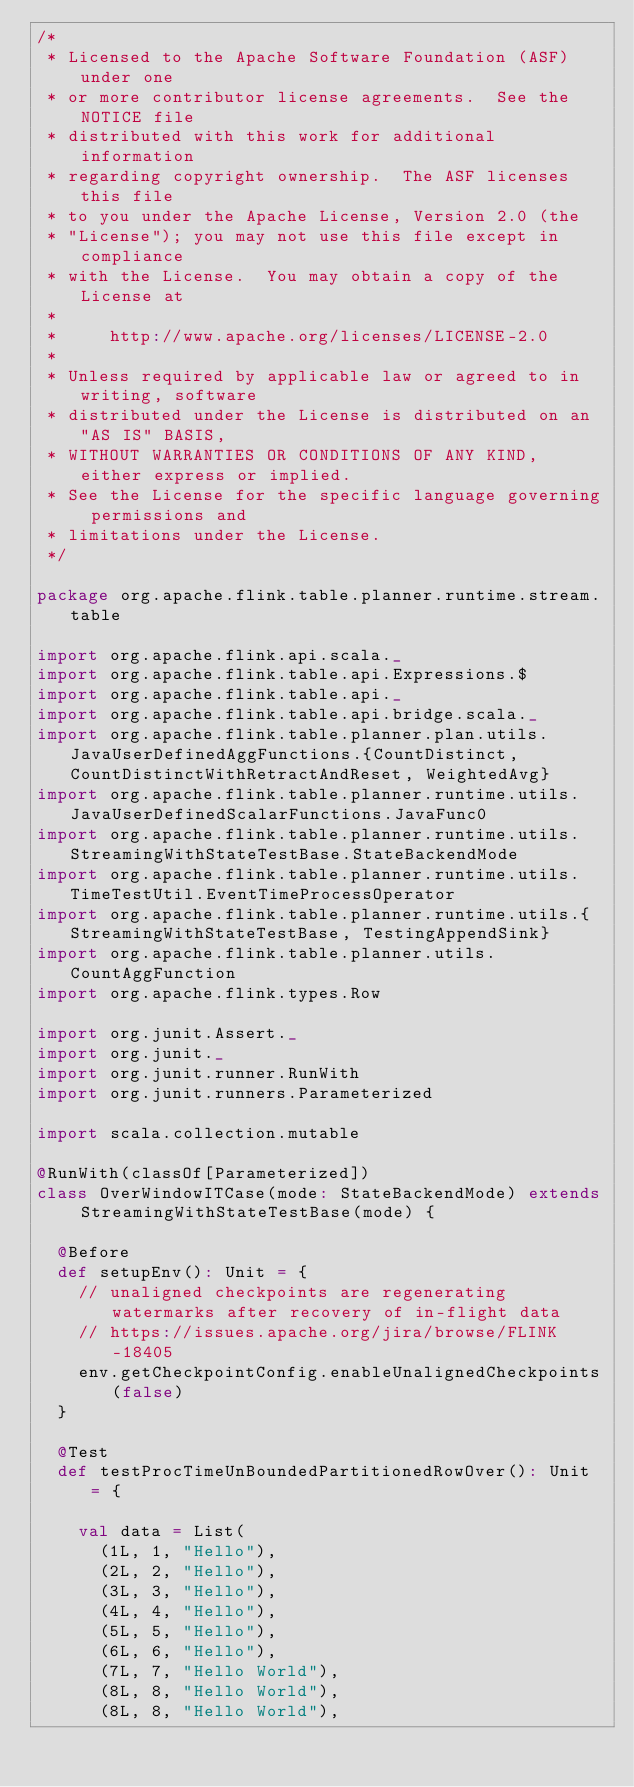<code> <loc_0><loc_0><loc_500><loc_500><_Scala_>/*
 * Licensed to the Apache Software Foundation (ASF) under one
 * or more contributor license agreements.  See the NOTICE file
 * distributed with this work for additional information
 * regarding copyright ownership.  The ASF licenses this file
 * to you under the Apache License, Version 2.0 (the
 * "License"); you may not use this file except in compliance
 * with the License.  You may obtain a copy of the License at
 *
 *     http://www.apache.org/licenses/LICENSE-2.0
 *
 * Unless required by applicable law or agreed to in writing, software
 * distributed under the License is distributed on an "AS IS" BASIS,
 * WITHOUT WARRANTIES OR CONDITIONS OF ANY KIND, either express or implied.
 * See the License for the specific language governing permissions and
 * limitations under the License.
 */

package org.apache.flink.table.planner.runtime.stream.table

import org.apache.flink.api.scala._
import org.apache.flink.table.api.Expressions.$
import org.apache.flink.table.api._
import org.apache.flink.table.api.bridge.scala._
import org.apache.flink.table.planner.plan.utils.JavaUserDefinedAggFunctions.{CountDistinct, CountDistinctWithRetractAndReset, WeightedAvg}
import org.apache.flink.table.planner.runtime.utils.JavaUserDefinedScalarFunctions.JavaFunc0
import org.apache.flink.table.planner.runtime.utils.StreamingWithStateTestBase.StateBackendMode
import org.apache.flink.table.planner.runtime.utils.TimeTestUtil.EventTimeProcessOperator
import org.apache.flink.table.planner.runtime.utils.{StreamingWithStateTestBase, TestingAppendSink}
import org.apache.flink.table.planner.utils.CountAggFunction
import org.apache.flink.types.Row

import org.junit.Assert._
import org.junit._
import org.junit.runner.RunWith
import org.junit.runners.Parameterized

import scala.collection.mutable

@RunWith(classOf[Parameterized])
class OverWindowITCase(mode: StateBackendMode) extends StreamingWithStateTestBase(mode) {

  @Before
  def setupEnv(): Unit = {
    // unaligned checkpoints are regenerating watermarks after recovery of in-flight data
    // https://issues.apache.org/jira/browse/FLINK-18405
    env.getCheckpointConfig.enableUnalignedCheckpoints(false)
  }

  @Test
  def testProcTimeUnBoundedPartitionedRowOver(): Unit = {

    val data = List(
      (1L, 1, "Hello"),
      (2L, 2, "Hello"),
      (3L, 3, "Hello"),
      (4L, 4, "Hello"),
      (5L, 5, "Hello"),
      (6L, 6, "Hello"),
      (7L, 7, "Hello World"),
      (8L, 8, "Hello World"),
      (8L, 8, "Hello World"),</code> 